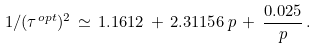<formula> <loc_0><loc_0><loc_500><loc_500>1 / ( \tau ^ { o p t } ) ^ { 2 } \, \simeq \, 1 . 1 6 1 2 \, + \, 2 . 3 1 1 5 6 \, p \, + \, { \frac { 0 . 0 2 5 } { p } } \, .</formula> 